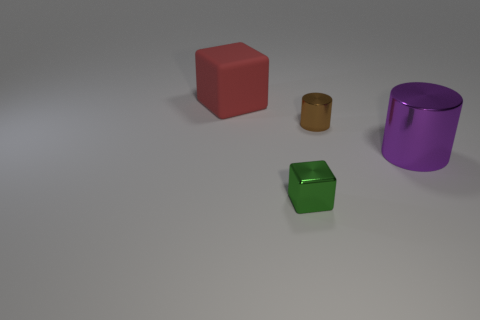Add 3 brown metal blocks. How many objects exist? 7 Add 4 large blue matte spheres. How many large blue matte spheres exist? 4 Subtract 0 blue blocks. How many objects are left? 4 Subtract all small green matte cylinders. Subtract all small brown metal things. How many objects are left? 3 Add 2 brown metal things. How many brown metal things are left? 3 